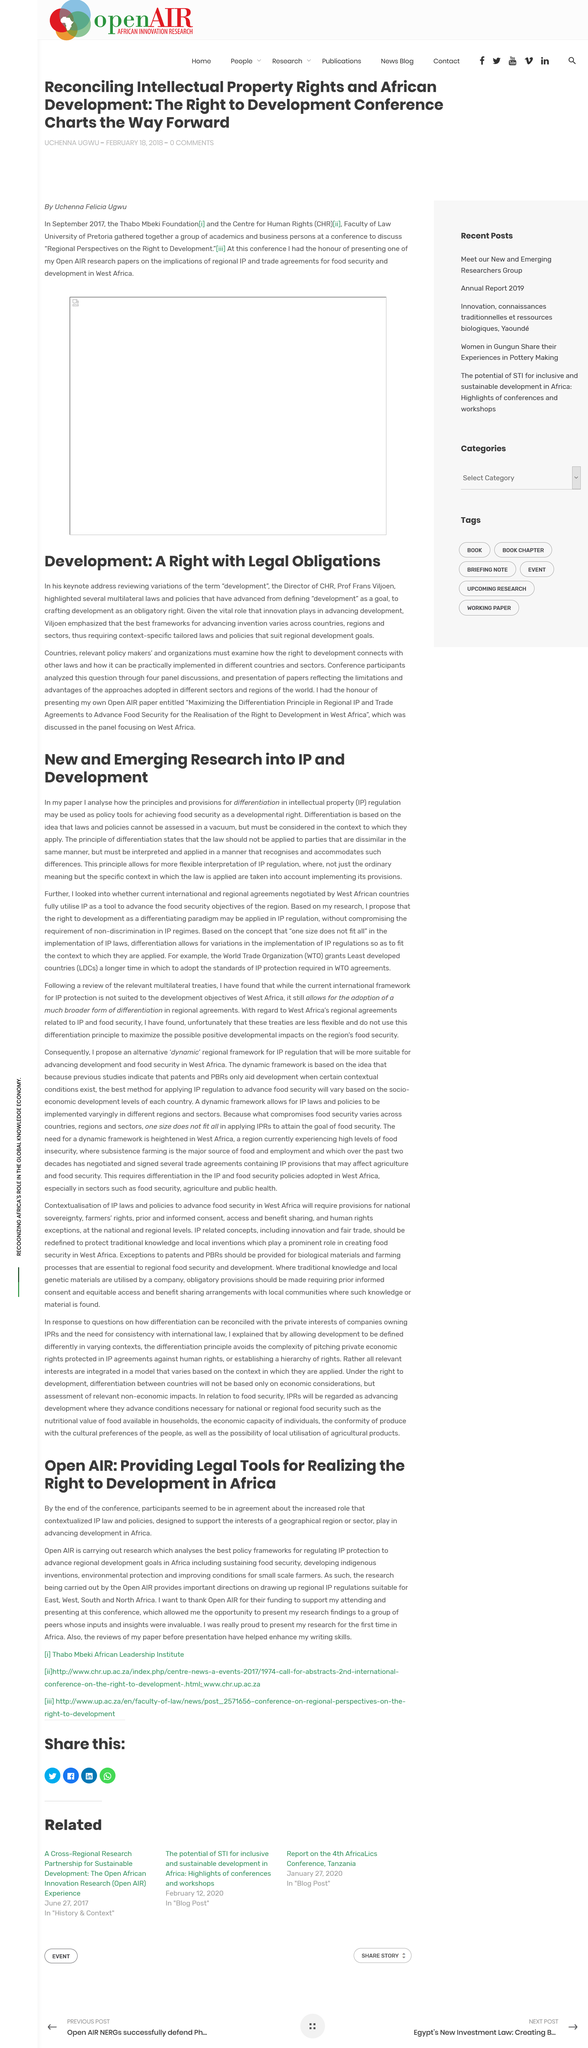Indicate a few pertinent items in this graphic. The conference title was not altered by the use of "Regional Perspectives on the" in the title. The article discusses research that examines the most effective policy frameworks for protecting intellectual property (IP), a two-letter abbreviation. The article discusses development in the continent of Africa, as indicated by the title of the article. Development goals are not universally applicable to all regions and require tailored laws and policies that are specific to each region's context. The principle of differentiation states that the laws should not be applied to parties that are dissimilar in the same manner. 